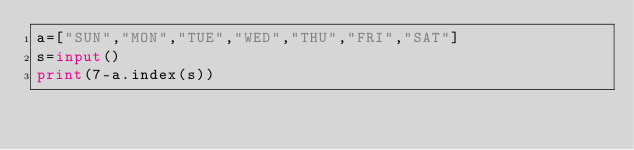<code> <loc_0><loc_0><loc_500><loc_500><_Python_>a=["SUN","MON","TUE","WED","THU","FRI","SAT"]
s=input()
print(7-a.index(s))</code> 